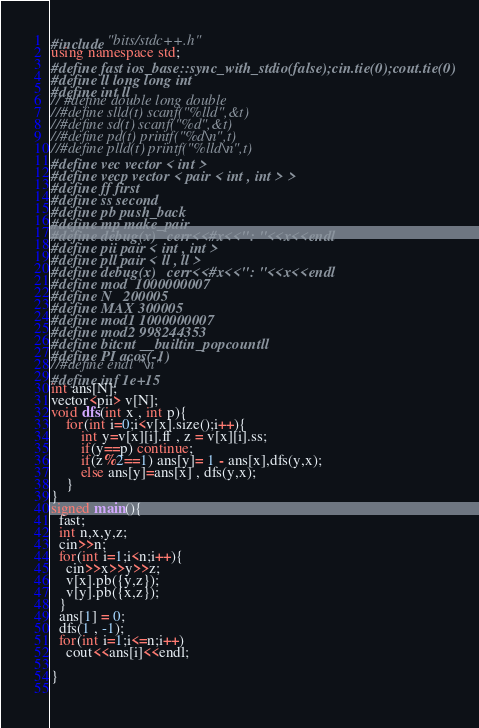<code> <loc_0><loc_0><loc_500><loc_500><_C++_>#include "bits/stdc++.h"
using namespace std;
#define fast ios_base::sync_with_stdio(false);cin.tie(0);cout.tie(0)
#define ll long long int
#define int ll
// #define double long double
//#define slld(t) scanf("%lld",&t)
//#define sd(t) scanf("%d",&t)
//#define pd(t) printf("%d\n",t)
//#define plld(t) printf("%lld\n",t)
#define vec vector < int >
#define vecp vector < pair < int , int > >
#define ff first
#define ss second
#define pb push_back
#define mp make_pair
#define debug(x)   cerr<<#x<<": "<<x<<endl
#define pii pair < int , int >
#define pll pair < ll , ll > 
#define debug(x)   cerr<<#x<<": "<<x<<endl
#define mod  1000000007
#define N   200005
#define MAX 300005
#define mod1 1000000007
#define mod2 998244353
#define bitcnt __builtin_popcountll
#define PI acos(-1)
//#define endl "\n"
#define inf 1e+15
int ans[N];
vector<pii> v[N];
void dfs(int x , int p){
	for(int i=0;i<v[x].size();i++){
		int y=v[x][i].ff , z = v[x][i].ss;
		if(y==p) continue;
		if(z%2==1) ans[y]= 1 - ans[x],dfs(y,x);
		else ans[y]=ans[x] , dfs(y,x);
	}
}
signed main(){
  fast;
  int n,x,y,z;
  cin>>n;
  for(int i=1;i<n;i++){
  	cin>>x>>y>>z;
  	v[x].pb({y,z});
  	v[y].pb({x,z});
  }
  ans[1] = 0;
  dfs(1 , -1);
  for(int i=1;i<=n;i++)
  	cout<<ans[i]<<endl;

}
  
</code> 